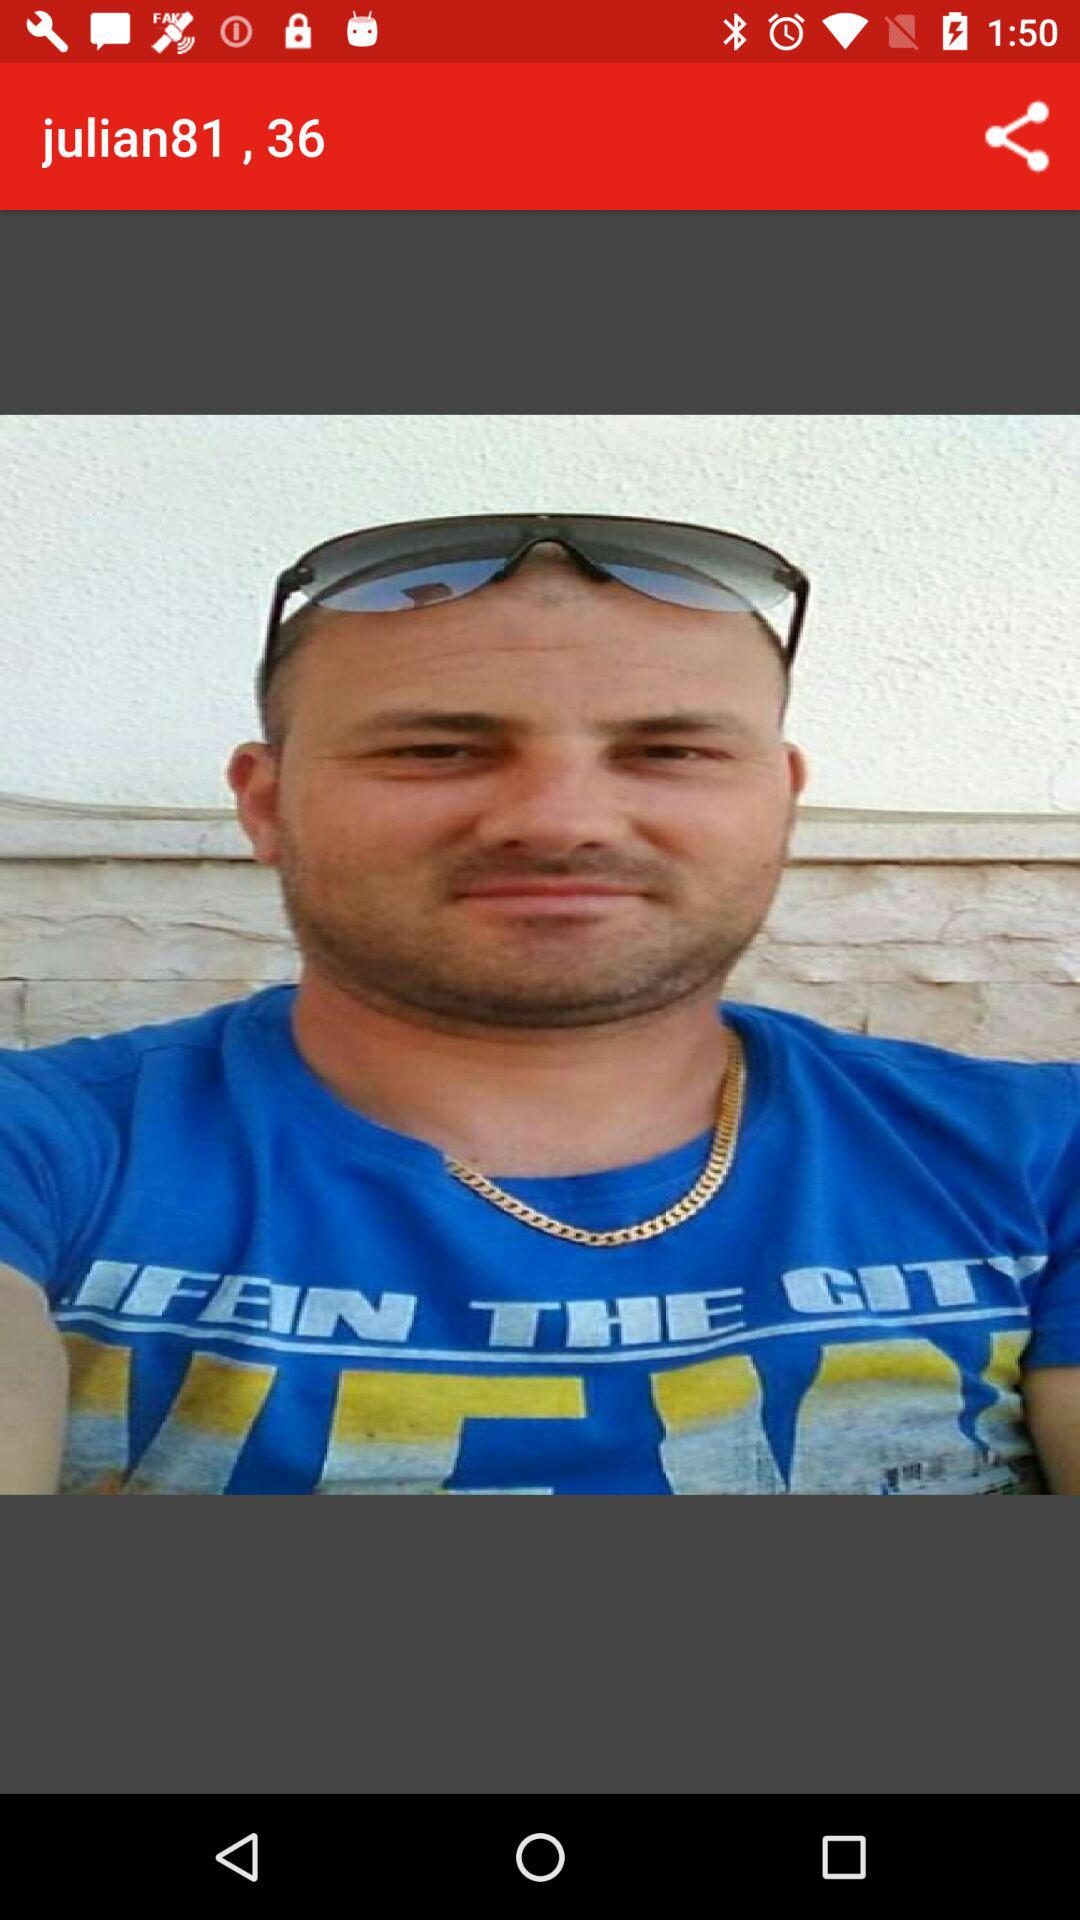What is the age of "julian81"? The age is 36. 